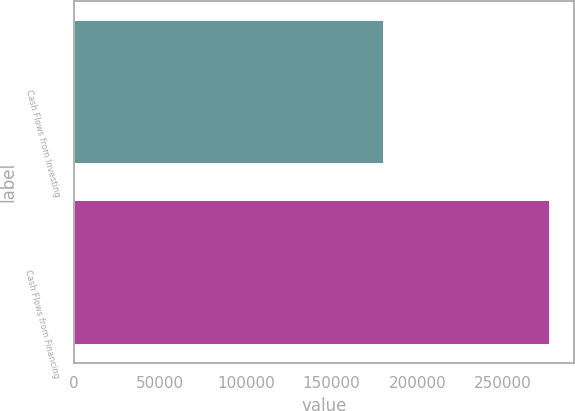<chart> <loc_0><loc_0><loc_500><loc_500><bar_chart><fcel>Cash Flows from Investing<fcel>Cash Flows from Financing<nl><fcel>180800<fcel>277430<nl></chart> 